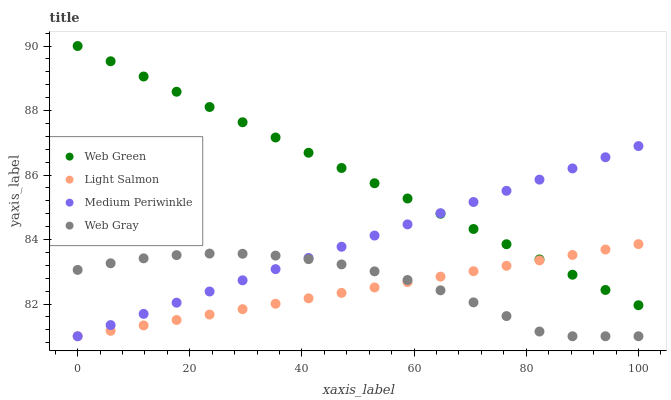Does Light Salmon have the minimum area under the curve?
Answer yes or no. Yes. Does Web Green have the maximum area under the curve?
Answer yes or no. Yes. Does Web Gray have the minimum area under the curve?
Answer yes or no. No. Does Web Gray have the maximum area under the curve?
Answer yes or no. No. Is Web Green the smoothest?
Answer yes or no. Yes. Is Web Gray the roughest?
Answer yes or no. Yes. Is Medium Periwinkle the smoothest?
Answer yes or no. No. Is Medium Periwinkle the roughest?
Answer yes or no. No. Does Light Salmon have the lowest value?
Answer yes or no. Yes. Does Web Green have the lowest value?
Answer yes or no. No. Does Web Green have the highest value?
Answer yes or no. Yes. Does Medium Periwinkle have the highest value?
Answer yes or no. No. Is Web Gray less than Web Green?
Answer yes or no. Yes. Is Web Green greater than Web Gray?
Answer yes or no. Yes. Does Web Green intersect Light Salmon?
Answer yes or no. Yes. Is Web Green less than Light Salmon?
Answer yes or no. No. Is Web Green greater than Light Salmon?
Answer yes or no. No. Does Web Gray intersect Web Green?
Answer yes or no. No. 